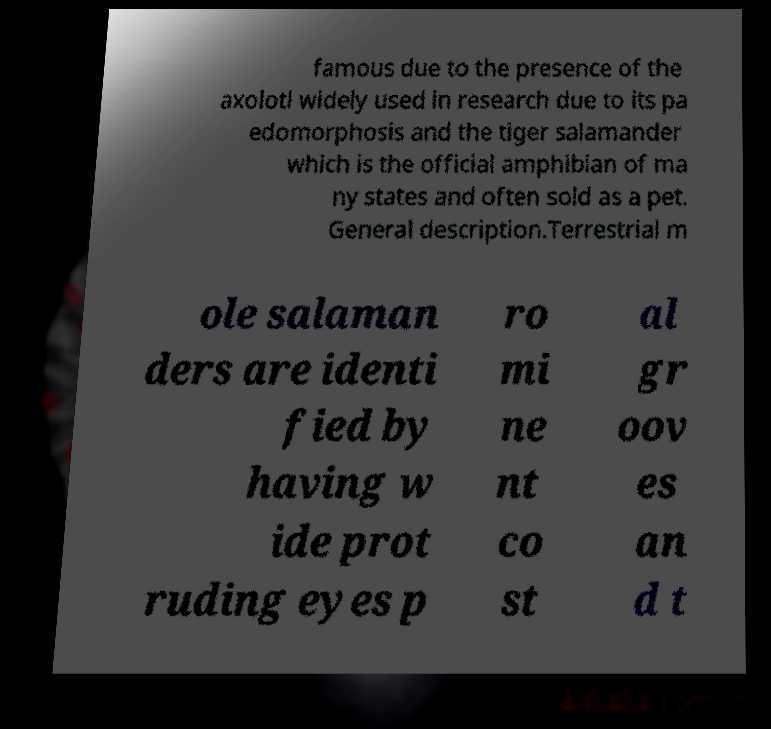There's text embedded in this image that I need extracted. Can you transcribe it verbatim? famous due to the presence of the axolotl widely used in research due to its pa edomorphosis and the tiger salamander which is the official amphibian of ma ny states and often sold as a pet. General description.Terrestrial m ole salaman ders are identi fied by having w ide prot ruding eyes p ro mi ne nt co st al gr oov es an d t 